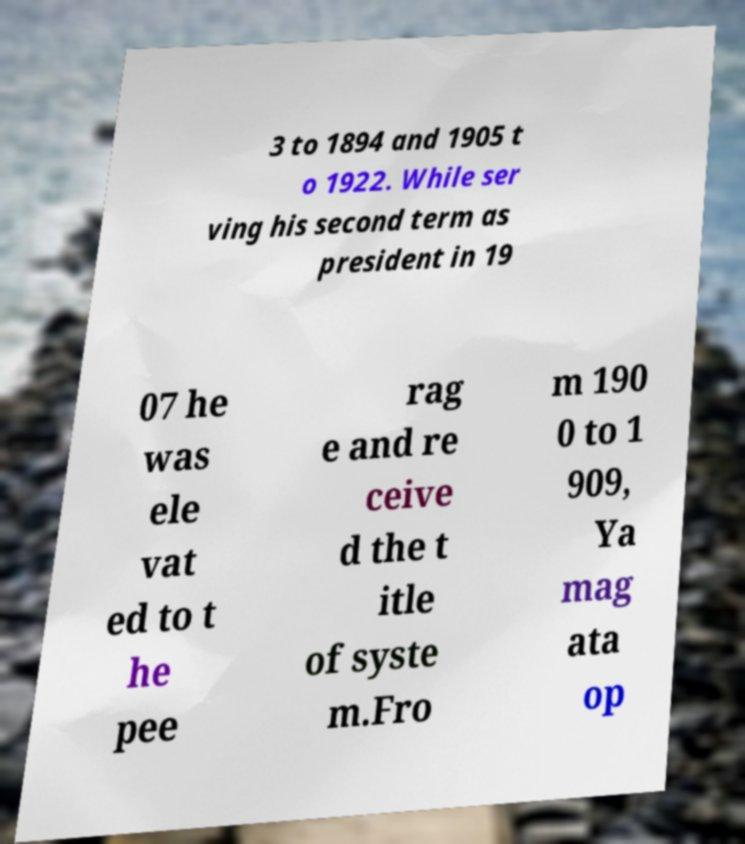Please identify and transcribe the text found in this image. 3 to 1894 and 1905 t o 1922. While ser ving his second term as president in 19 07 he was ele vat ed to t he pee rag e and re ceive d the t itle of syste m.Fro m 190 0 to 1 909, Ya mag ata op 